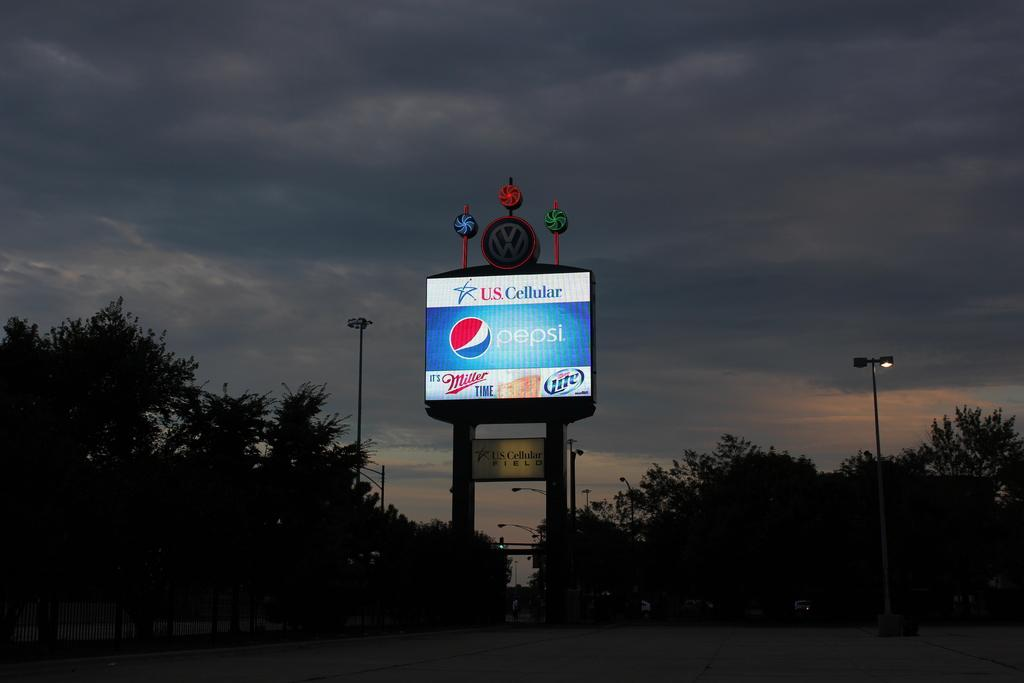<image>
Present a compact description of the photo's key features. a Pepsi billboard sponsored by US Cellular lit up in the dark 